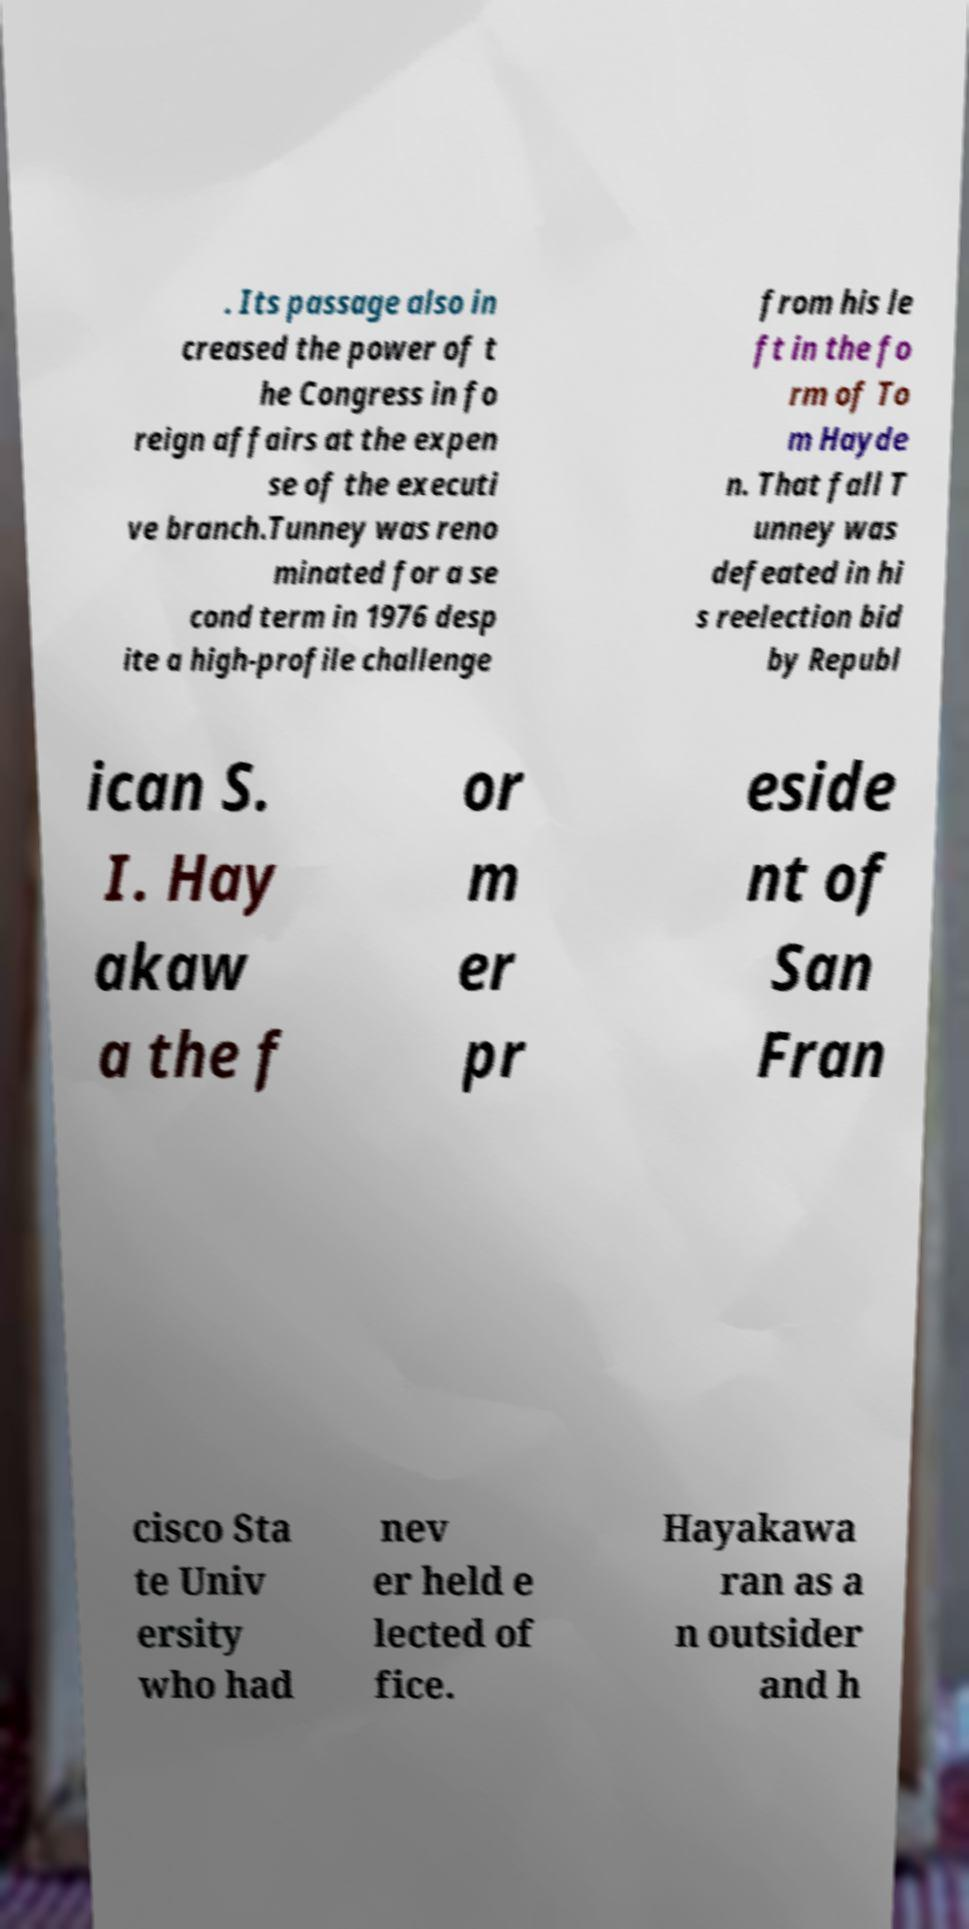Could you assist in decoding the text presented in this image and type it out clearly? . Its passage also in creased the power of t he Congress in fo reign affairs at the expen se of the executi ve branch.Tunney was reno minated for a se cond term in 1976 desp ite a high-profile challenge from his le ft in the fo rm of To m Hayde n. That fall T unney was defeated in hi s reelection bid by Republ ican S. I. Hay akaw a the f or m er pr eside nt of San Fran cisco Sta te Univ ersity who had nev er held e lected of fice. Hayakawa ran as a n outsider and h 